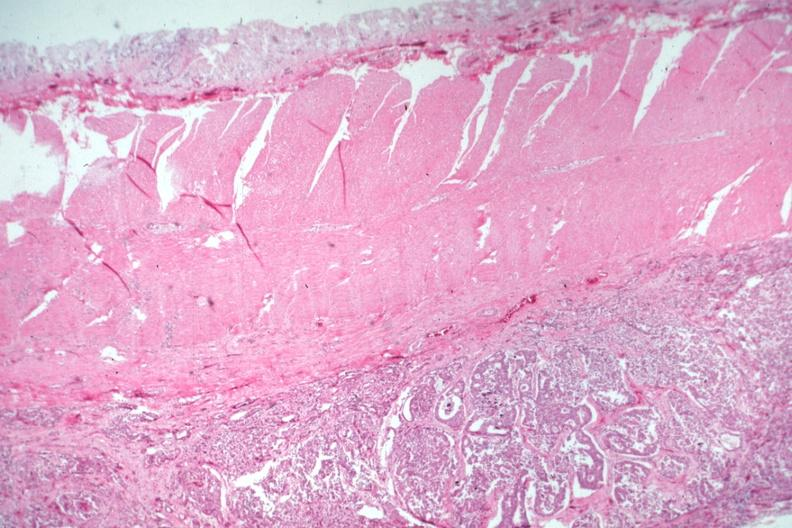s metastatic carcinoma present?
Answer the question using a single word or phrase. Yes 